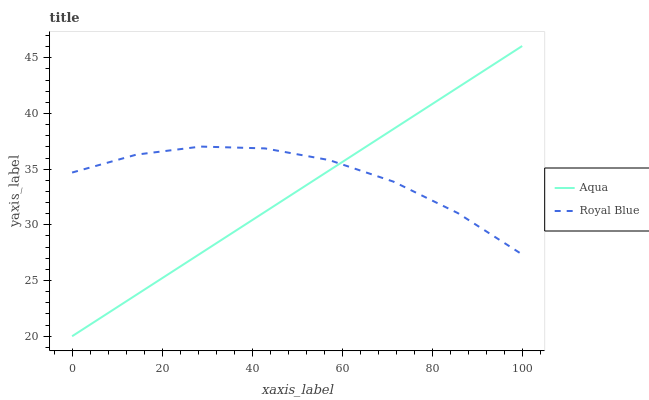Does Aqua have the minimum area under the curve?
Answer yes or no. Yes. Does Royal Blue have the maximum area under the curve?
Answer yes or no. Yes. Does Aqua have the maximum area under the curve?
Answer yes or no. No. Is Aqua the smoothest?
Answer yes or no. Yes. Is Royal Blue the roughest?
Answer yes or no. Yes. Is Aqua the roughest?
Answer yes or no. No. Does Aqua have the lowest value?
Answer yes or no. Yes. Does Aqua have the highest value?
Answer yes or no. Yes. Does Aqua intersect Royal Blue?
Answer yes or no. Yes. Is Aqua less than Royal Blue?
Answer yes or no. No. Is Aqua greater than Royal Blue?
Answer yes or no. No. 